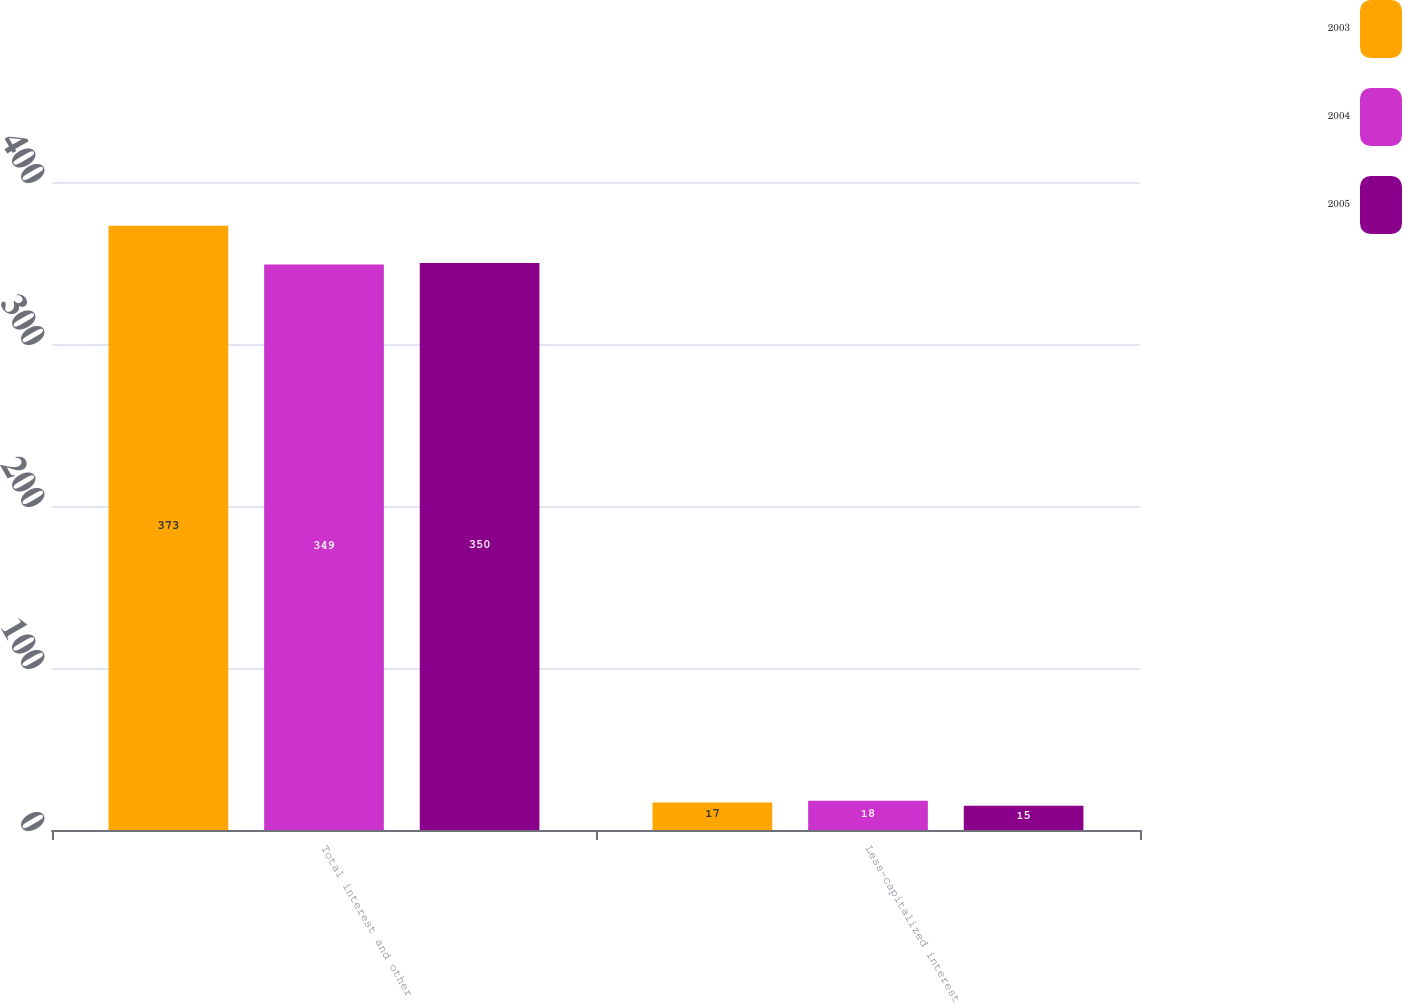Convert chart to OTSL. <chart><loc_0><loc_0><loc_500><loc_500><stacked_bar_chart><ecel><fcel>Total interest and other<fcel>Less-capitalized interest<nl><fcel>2003<fcel>373<fcel>17<nl><fcel>2004<fcel>349<fcel>18<nl><fcel>2005<fcel>350<fcel>15<nl></chart> 